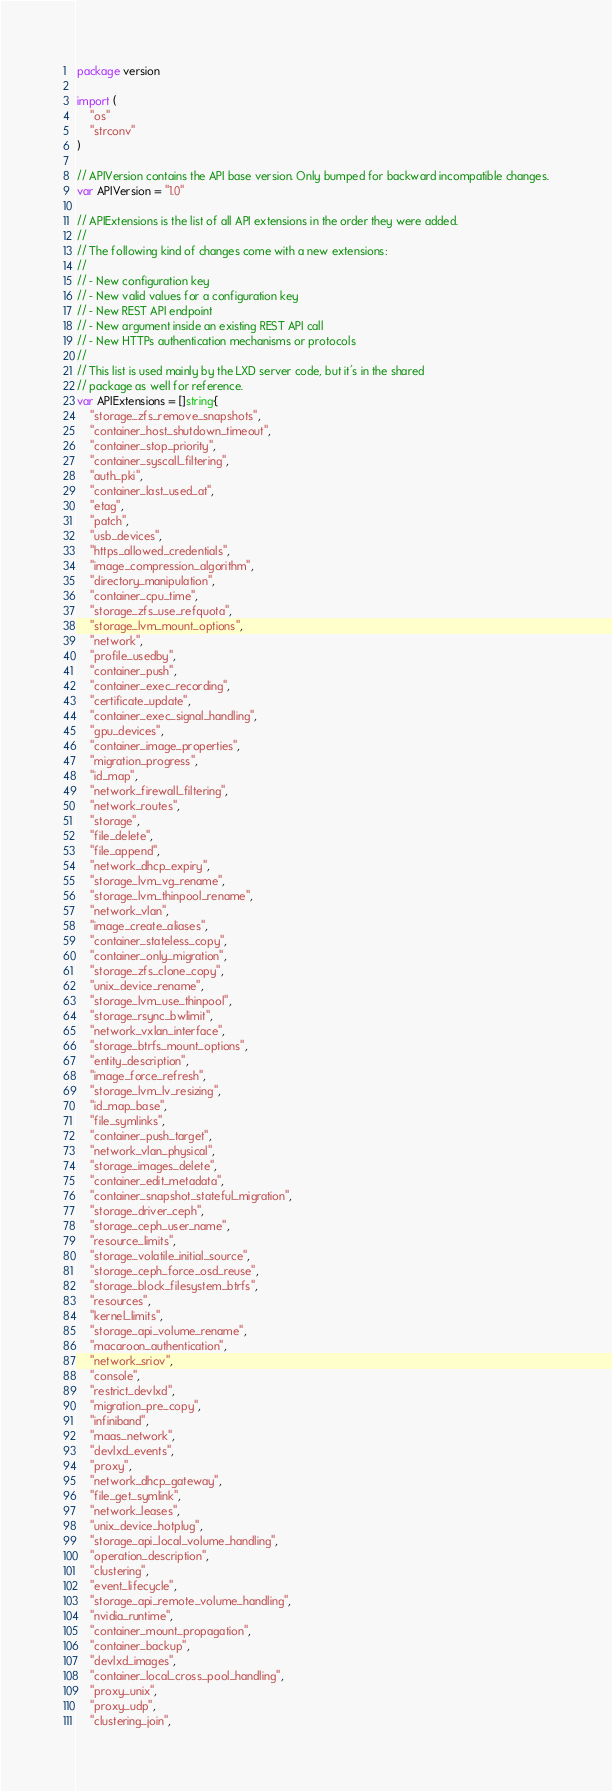<code> <loc_0><loc_0><loc_500><loc_500><_Go_>package version

import (
	"os"
	"strconv"
)

// APIVersion contains the API base version. Only bumped for backward incompatible changes.
var APIVersion = "1.0"

// APIExtensions is the list of all API extensions in the order they were added.
//
// The following kind of changes come with a new extensions:
//
// - New configuration key
// - New valid values for a configuration key
// - New REST API endpoint
// - New argument inside an existing REST API call
// - New HTTPs authentication mechanisms or protocols
//
// This list is used mainly by the LXD server code, but it's in the shared
// package as well for reference.
var APIExtensions = []string{
	"storage_zfs_remove_snapshots",
	"container_host_shutdown_timeout",
	"container_stop_priority",
	"container_syscall_filtering",
	"auth_pki",
	"container_last_used_at",
	"etag",
	"patch",
	"usb_devices",
	"https_allowed_credentials",
	"image_compression_algorithm",
	"directory_manipulation",
	"container_cpu_time",
	"storage_zfs_use_refquota",
	"storage_lvm_mount_options",
	"network",
	"profile_usedby",
	"container_push",
	"container_exec_recording",
	"certificate_update",
	"container_exec_signal_handling",
	"gpu_devices",
	"container_image_properties",
	"migration_progress",
	"id_map",
	"network_firewall_filtering",
	"network_routes",
	"storage",
	"file_delete",
	"file_append",
	"network_dhcp_expiry",
	"storage_lvm_vg_rename",
	"storage_lvm_thinpool_rename",
	"network_vlan",
	"image_create_aliases",
	"container_stateless_copy",
	"container_only_migration",
	"storage_zfs_clone_copy",
	"unix_device_rename",
	"storage_lvm_use_thinpool",
	"storage_rsync_bwlimit",
	"network_vxlan_interface",
	"storage_btrfs_mount_options",
	"entity_description",
	"image_force_refresh",
	"storage_lvm_lv_resizing",
	"id_map_base",
	"file_symlinks",
	"container_push_target",
	"network_vlan_physical",
	"storage_images_delete",
	"container_edit_metadata",
	"container_snapshot_stateful_migration",
	"storage_driver_ceph",
	"storage_ceph_user_name",
	"resource_limits",
	"storage_volatile_initial_source",
	"storage_ceph_force_osd_reuse",
	"storage_block_filesystem_btrfs",
	"resources",
	"kernel_limits",
	"storage_api_volume_rename",
	"macaroon_authentication",
	"network_sriov",
	"console",
	"restrict_devlxd",
	"migration_pre_copy",
	"infiniband",
	"maas_network",
	"devlxd_events",
	"proxy",
	"network_dhcp_gateway",
	"file_get_symlink",
	"network_leases",
	"unix_device_hotplug",
	"storage_api_local_volume_handling",
	"operation_description",
	"clustering",
	"event_lifecycle",
	"storage_api_remote_volume_handling",
	"nvidia_runtime",
	"container_mount_propagation",
	"container_backup",
	"devlxd_images",
	"container_local_cross_pool_handling",
	"proxy_unix",
	"proxy_udp",
	"clustering_join",</code> 